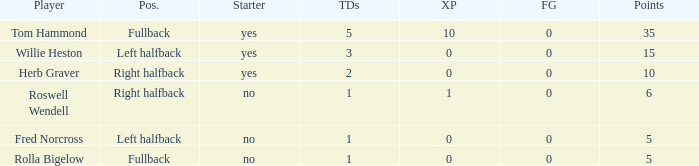How many extra points did right halfback Roswell Wendell have? 1.0. 